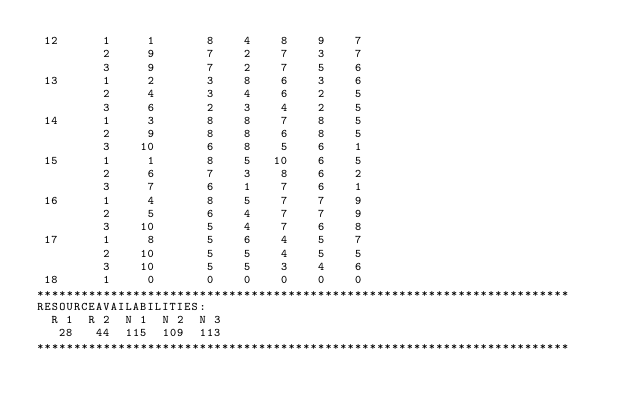<code> <loc_0><loc_0><loc_500><loc_500><_ObjectiveC_> 12      1     1       8    4    8    9    7
         2     9       7    2    7    3    7
         3     9       7    2    7    5    6
 13      1     2       3    8    6    3    6
         2     4       3    4    6    2    5
         3     6       2    3    4    2    5
 14      1     3       8    8    7    8    5
         2     9       8    8    6    8    5
         3    10       6    8    5    6    1
 15      1     1       8    5   10    6    5
         2     6       7    3    8    6    2
         3     7       6    1    7    6    1
 16      1     4       8    5    7    7    9
         2     5       6    4    7    7    9
         3    10       5    4    7    6    8
 17      1     8       5    6    4    5    7
         2    10       5    5    4    5    5
         3    10       5    5    3    4    6
 18      1     0       0    0    0    0    0
************************************************************************
RESOURCEAVAILABILITIES:
  R 1  R 2  N 1  N 2  N 3
   28   44  115  109  113
************************************************************************
</code> 